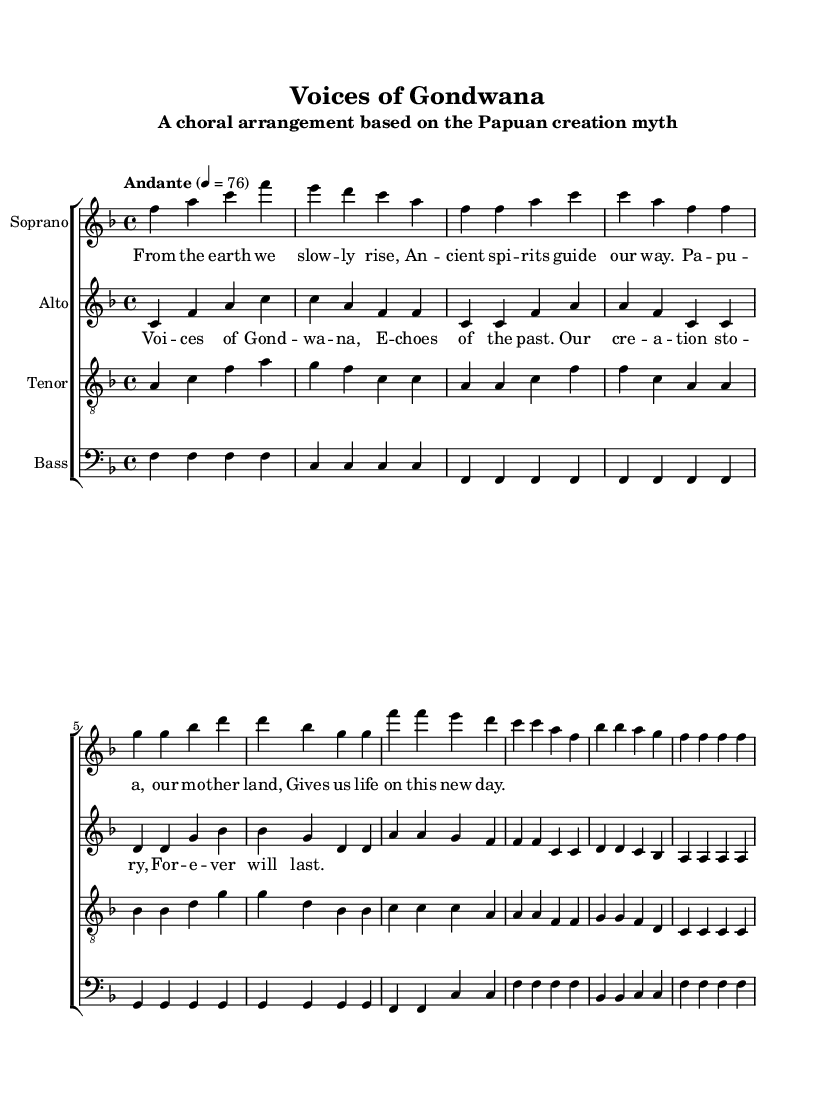What is the key signature of this music? The key signature is F major, which has one flat (B flat). You can identify the key signature on the left side of the staff, where it shows one flat note in the signature.
Answer: F major What is the time signature of the piece? The time signature is 4/4, which indicates four beats per measure and a quarter note gets one beat. You can find it at the beginning of the score, represented as a fraction (4 over 4).
Answer: 4/4 What is the tempo marking of this piece? The tempo marking indicates "Andante," which means a moderately slow pace in music. This is specified at the beginning of the score with a description next to the note value (4 = 76) depicting beats per minute.
Answer: Andante How many vocal parts are in this arrangement? There are four vocal parts: Soprano, Alto, Tenor, and Bass. This can be determined by looking at the labels for each staff in the score, which names each vocal part accordingly.
Answer: Four What is the title of the composition? The title of the composition is "Voices of Gondwana." This is stated at the top of the score in the header section, prominently displayed.
Answer: Voices of Gondwana What thematic element is highlighted in the lyrics? The thematic element highlighted in the lyrics is "creation story." This can be inferred by examining the lyrics provided, which mention elements of earth, spirits, and creation, mirroring the purpose of the piece.
Answer: Creation story What does the phrase "From the earth we slowly rise" suggest in a cultural context? The phrase suggests a connection to ancestral roots and the significance of land in Papuan culture. This is relevant because it reflects the importance of land and origins in many Papuan creation myths.
Answer: Ancestral roots 